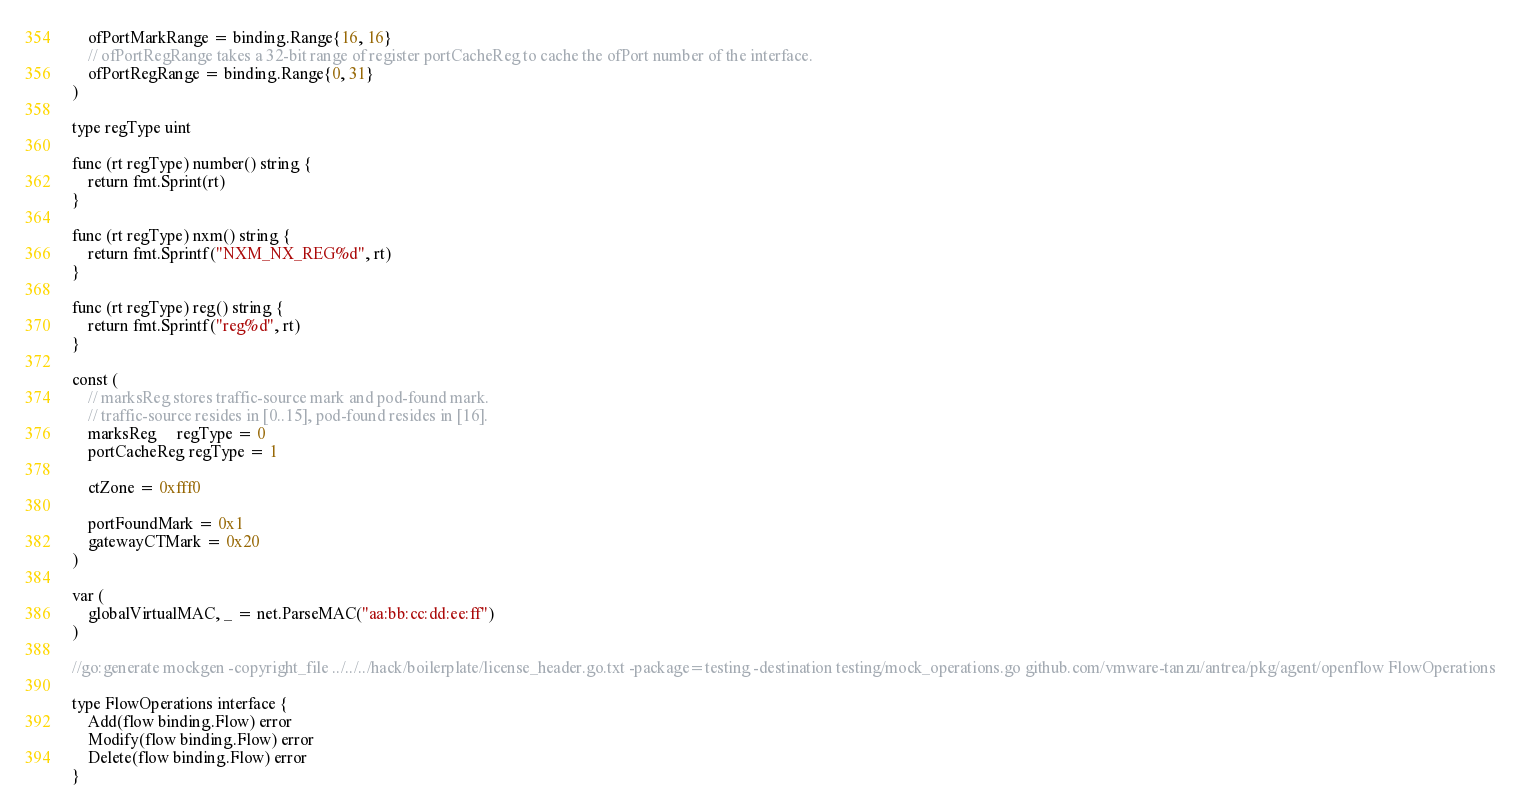Convert code to text. <code><loc_0><loc_0><loc_500><loc_500><_Go_>	ofPortMarkRange = binding.Range{16, 16}
	// ofPortRegRange takes a 32-bit range of register portCacheReg to cache the ofPort number of the interface.
	ofPortRegRange = binding.Range{0, 31}
)

type regType uint

func (rt regType) number() string {
	return fmt.Sprint(rt)
}

func (rt regType) nxm() string {
	return fmt.Sprintf("NXM_NX_REG%d", rt)
}

func (rt regType) reg() string {
	return fmt.Sprintf("reg%d", rt)
}

const (
	// marksReg stores traffic-source mark and pod-found mark.
	// traffic-source resides in [0..15], pod-found resides in [16].
	marksReg     regType = 0
	portCacheReg regType = 1

	ctZone = 0xfff0

	portFoundMark = 0x1
	gatewayCTMark = 0x20
)

var (
	globalVirtualMAC, _ = net.ParseMAC("aa:bb:cc:dd:ee:ff")
)

//go:generate mockgen -copyright_file ../../../hack/boilerplate/license_header.go.txt -package=testing -destination testing/mock_operations.go github.com/vmware-tanzu/antrea/pkg/agent/openflow FlowOperations

type FlowOperations interface {
	Add(flow binding.Flow) error
	Modify(flow binding.Flow) error
	Delete(flow binding.Flow) error
}
</code> 